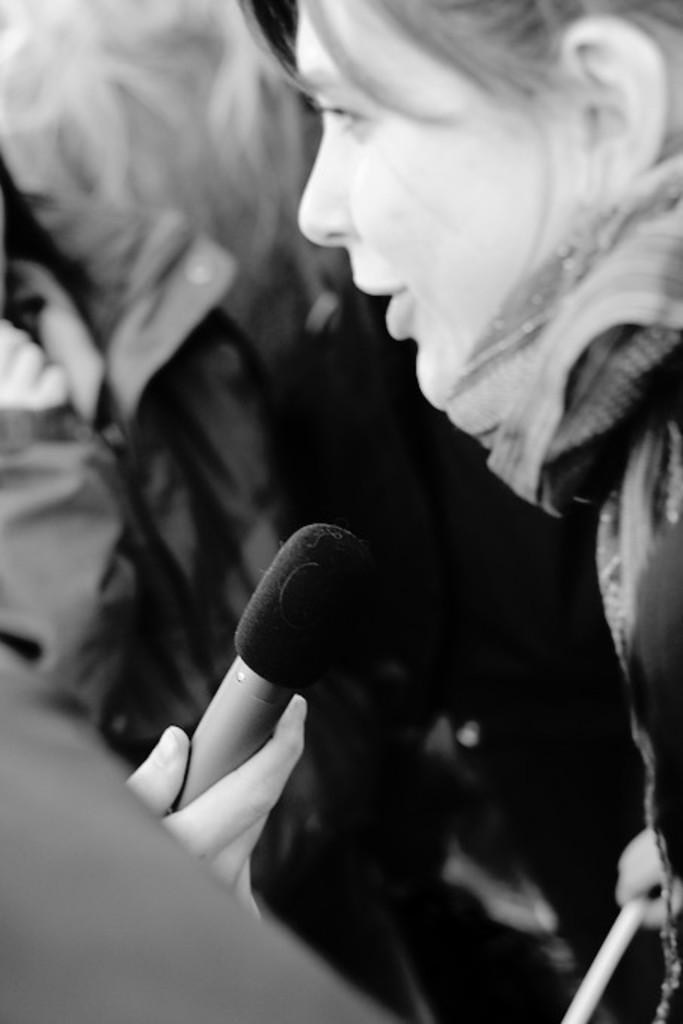What is the color scheme of the image? The image is black and white. Can you describe the subjects in the image? There are people in the image. What is a person doing with their hand on the left side of the image? A person's hand is holding a microphone on the left side of the image. How does the girl in the image provide support and guidance to the audience? There is no girl present in the image, and therefore no such support or guidance can be observed. 